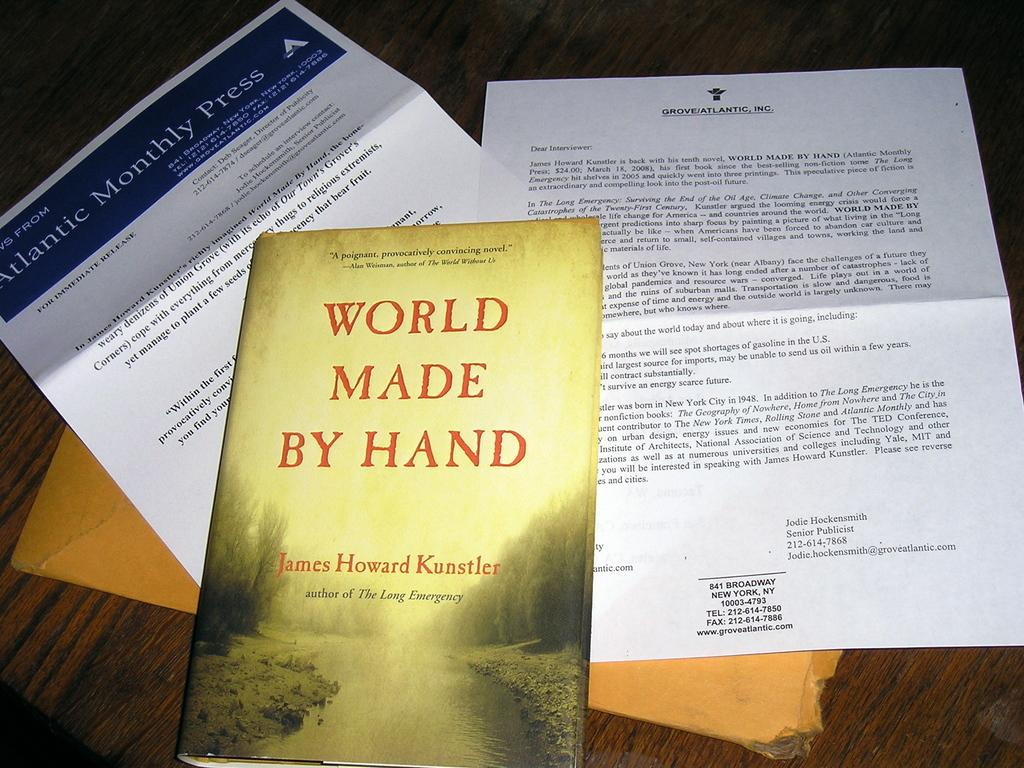<image>
Render a clear and concise summary of the photo. A paperback book sits atop of a letter from Atlantic Monthly Press. 